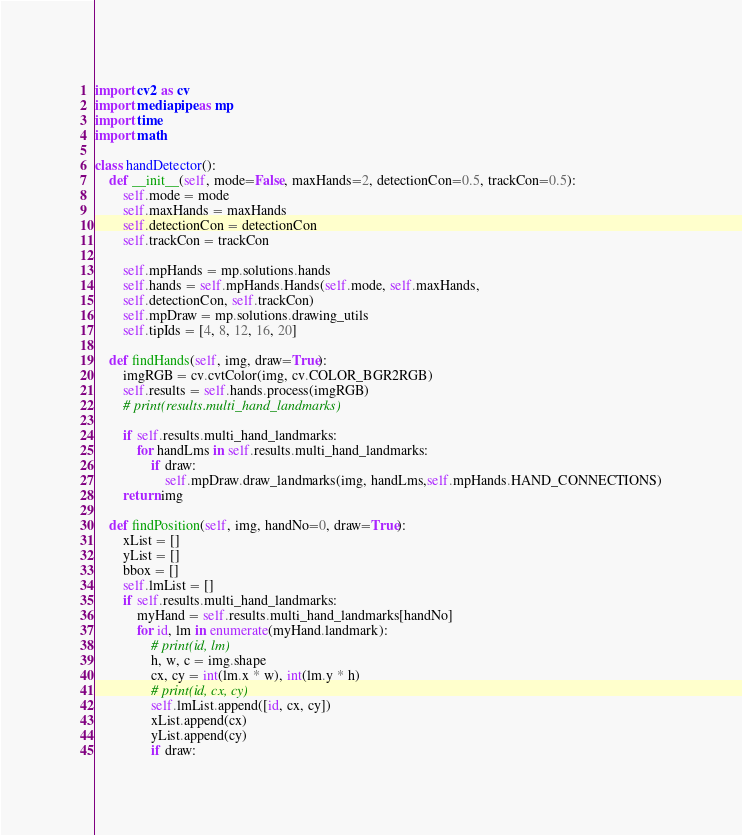Convert code to text. <code><loc_0><loc_0><loc_500><loc_500><_Python_>import cv2 as cv
import mediapipe as mp
import time
import math

class handDetector():
    def __init__(self, mode=False, maxHands=2, detectionCon=0.5, trackCon=0.5):
        self.mode = mode
        self.maxHands = maxHands
        self.detectionCon = detectionCon
        self.trackCon = trackCon

        self.mpHands = mp.solutions.hands
        self.hands = self.mpHands.Hands(self.mode, self.maxHands,
        self.detectionCon, self.trackCon)
        self.mpDraw = mp.solutions.drawing_utils
        self.tipIds = [4, 8, 12, 16, 20]

    def findHands(self, img, draw=True):
        imgRGB = cv.cvtColor(img, cv.COLOR_BGR2RGB)
        self.results = self.hands.process(imgRGB)
        # print(results.multi_hand_landmarks)

        if self.results.multi_hand_landmarks:
            for handLms in self.results.multi_hand_landmarks:
                if draw:
                    self.mpDraw.draw_landmarks(img, handLms,self.mpHands.HAND_CONNECTIONS)
        return img

    def findPosition(self, img, handNo=0, draw=True):
        xList = []
        yList = []
        bbox = []
        self.lmList = []
        if self.results.multi_hand_landmarks:
            myHand = self.results.multi_hand_landmarks[handNo]
            for id, lm in enumerate(myHand.landmark):
                # print(id, lm)
                h, w, c = img.shape
                cx, cy = int(lm.x * w), int(lm.y * h)
                # print(id, cx, cy)
                self.lmList.append([id, cx, cy])
                xList.append(cx)
                yList.append(cy)
                if draw:</code> 